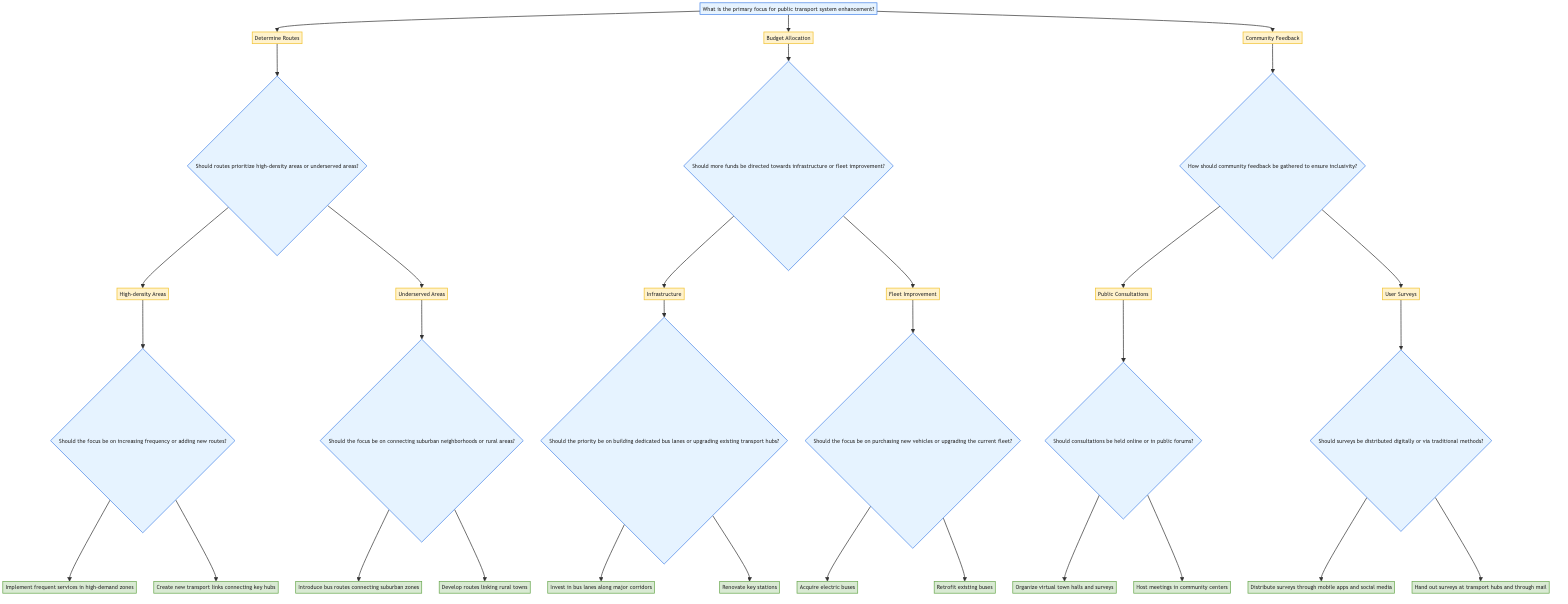What is the primary focus for public transport system enhancement? The root node of the decision tree identifies the primary focus for enhancing the public transport system. According to the diagram, the primary focus is split into three main categories: Determine Routes, Budget Allocation, and Community Feedback.
Answer: Determine Routes, Budget Allocation, Community Feedback How many options are there under the "Budget Allocation" node? By examining the "Budget Allocation" section of the tree, we can see that there are two options listed: Infrastructure and Fleet Improvement. Therefore, the count is straightforward.
Answer: 2 What should the priority be if focusing on "Infrastructure"? Following the path from "Budget Allocation" to "Infrastructure", we can see two additional options: building dedicated bus lanes or upgrading existing transport hubs. The diagram explicitly states that these are the priorities.
Answer: Building dedicated bus lanes, upgrading existing transport hubs What action is suggested if the focus is on "High-density Areas" and "Increase Frequency"? Starting from "Determine Routes" to "High-density Areas", and then to "Increase Frequency", we find that the suggested action is to implement frequent services. The diagram clearly outlines the necessary step to enhance the transport services in that context.
Answer: Implement frequent services in high-demand zones If choosing "User Surveys," what method is proposed for distribution? If we start at "Community Feedback" and move to "User Surveys", we notice a further division in methods for distributing surveys: digital or traditional methods. The diagram directly mentions that if choosing User Surveys, distributing them through mobile apps and social media platforms is the suggested approach.
Answer: Distribute surveys through mobile apps and social media platforms What are the two considerations for collecting community feedback? Referring to the "Community Feedback" section, we can identify that the options provided for collecting feedback are Public Consultations and User Surveys. These are the two main categories illustrated in the tree.
Answer: Public Consultations, User Surveys Should the focus for routes prioritize suburban neighborhoods or rural areas if choosing "Underserved Areas"? Looking into "Underserved Areas", the decision tree branches into two considerations: connecting suburban neighborhoods and connecting rural areas. It highlights the options available if going down this path.
Answer: Connecting suburban neighborhoods, connecting rural areas What is one proposed action under "Public Consultations" if consultations are held in public forums? Beginning at "Community Feedback", proceeding to "Public Consultations", and then to its child node that specifies consultations in public forums, we see that the proposed action is to host meetings. This conclusion is direct and evident from the diagram.
Answer: Host meetings in community centers 